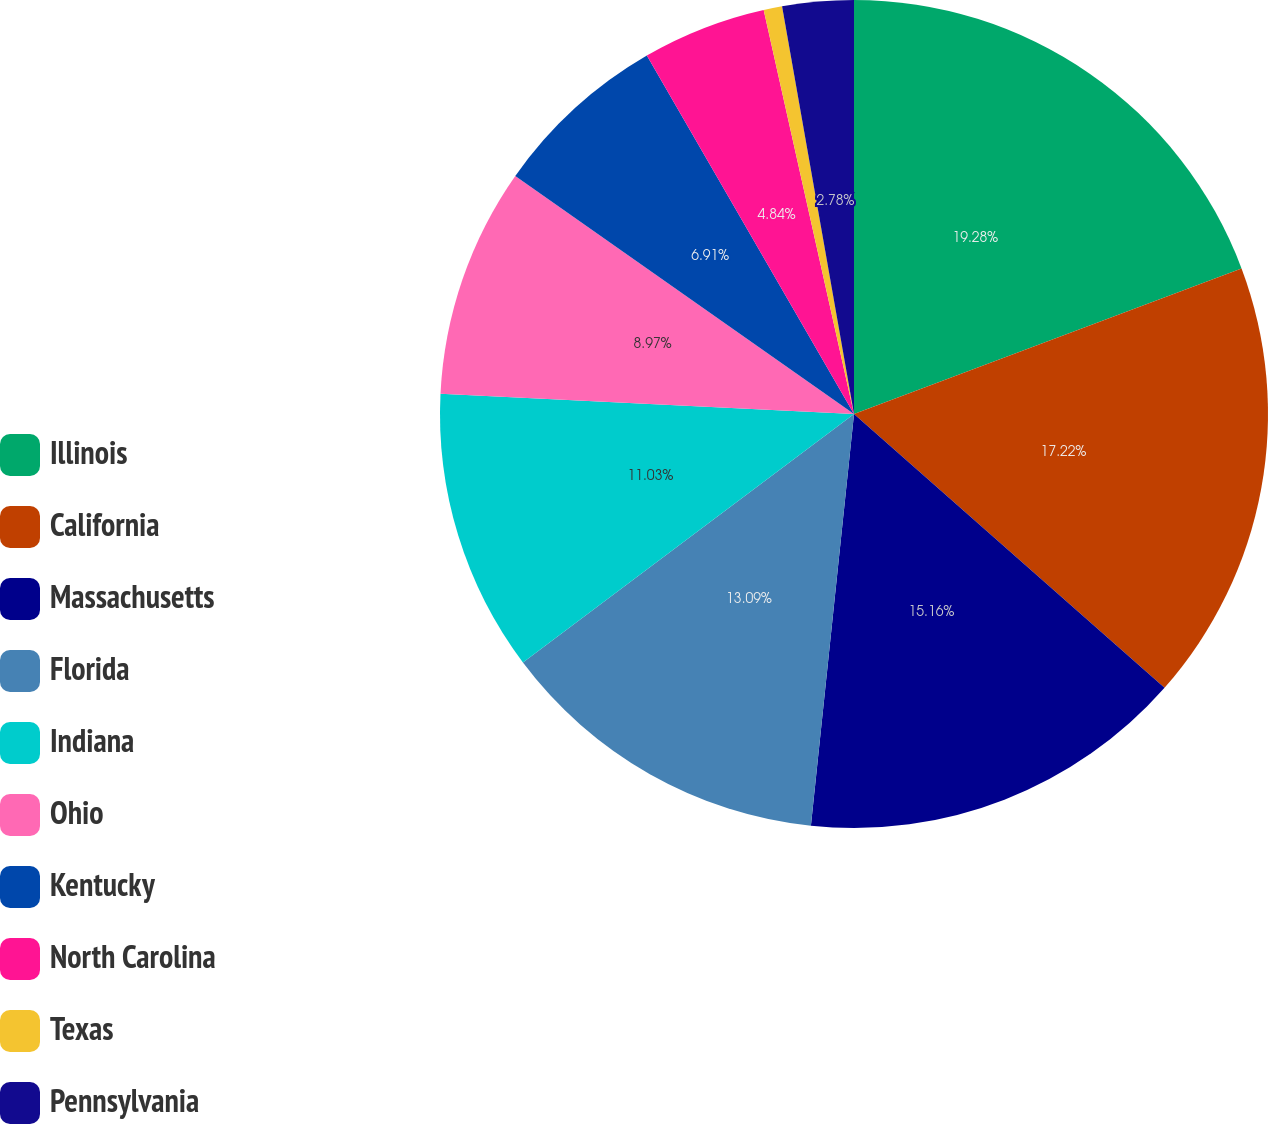Convert chart. <chart><loc_0><loc_0><loc_500><loc_500><pie_chart><fcel>Illinois<fcel>California<fcel>Massachusetts<fcel>Florida<fcel>Indiana<fcel>Ohio<fcel>Kentucky<fcel>North Carolina<fcel>Texas<fcel>Pennsylvania<nl><fcel>19.28%<fcel>17.22%<fcel>15.16%<fcel>13.09%<fcel>11.03%<fcel>8.97%<fcel>6.91%<fcel>4.84%<fcel>0.72%<fcel>2.78%<nl></chart> 